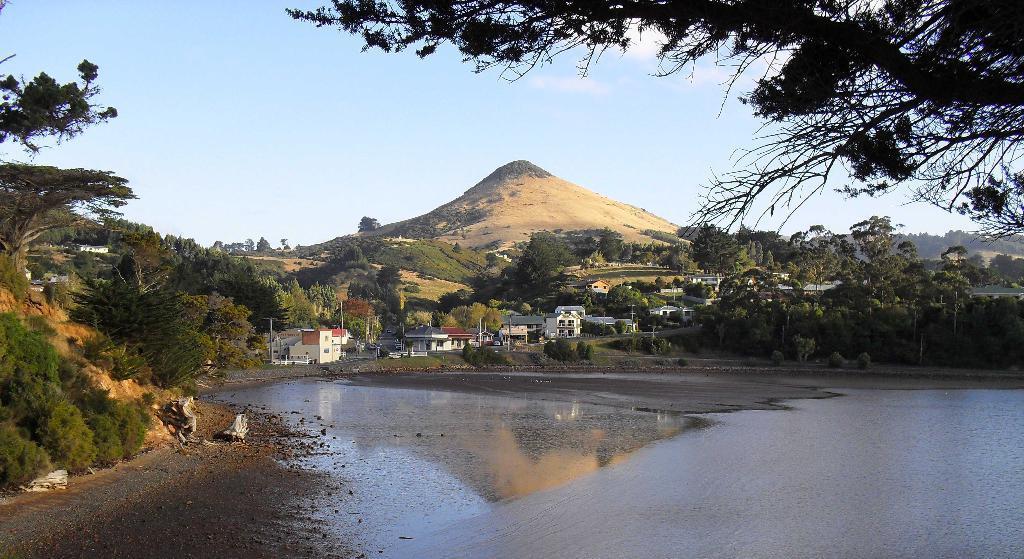Please provide a concise description of this image. In this image in the center there is water. On the left side there are trees. In the background there are buildings and there are trees. On the right side there are trees and the sky is cloudy. 